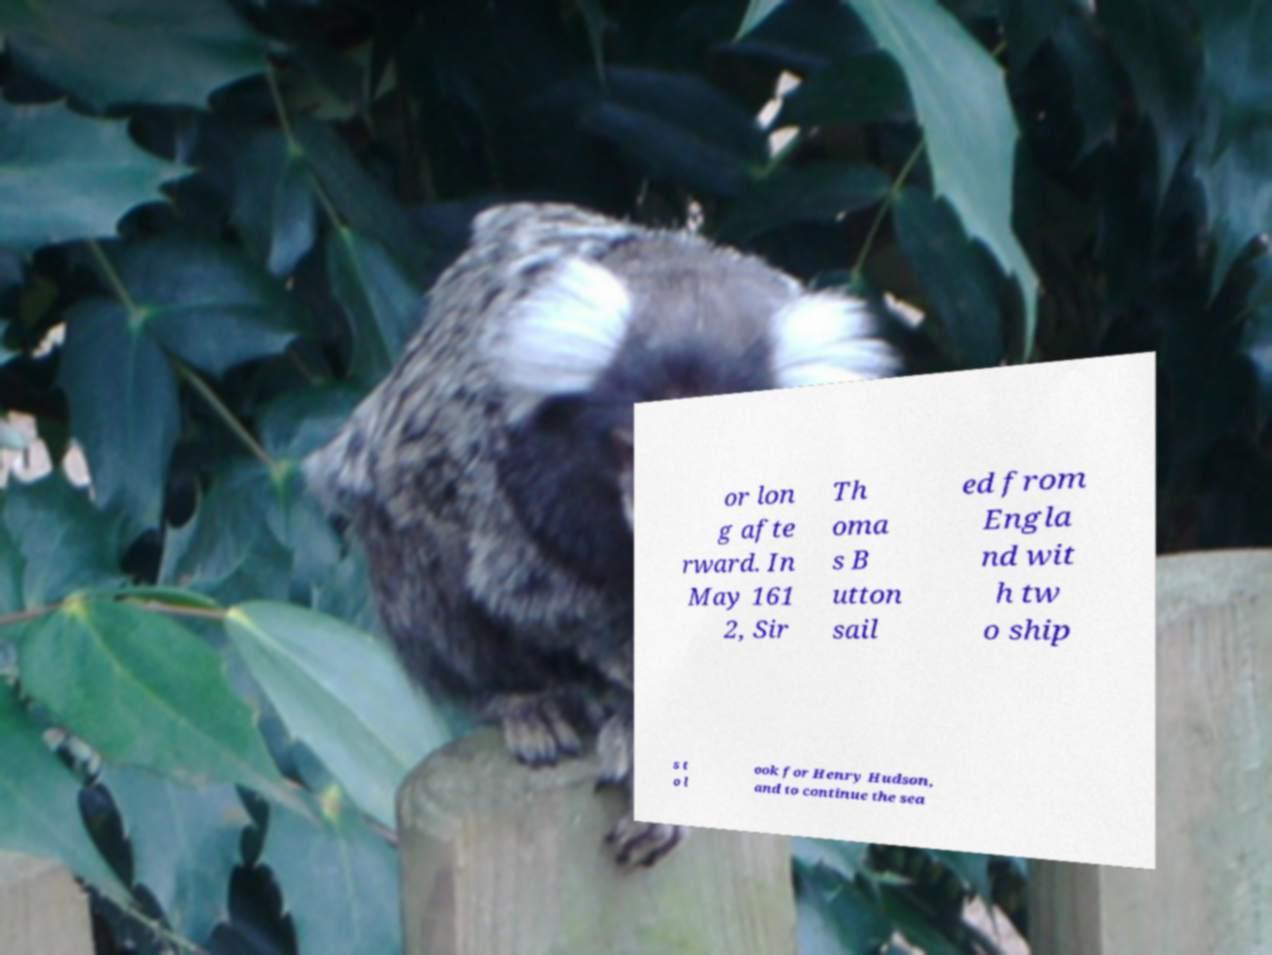Can you read and provide the text displayed in the image?This photo seems to have some interesting text. Can you extract and type it out for me? or lon g afte rward. In May 161 2, Sir Th oma s B utton sail ed from Engla nd wit h tw o ship s t o l ook for Henry Hudson, and to continue the sea 